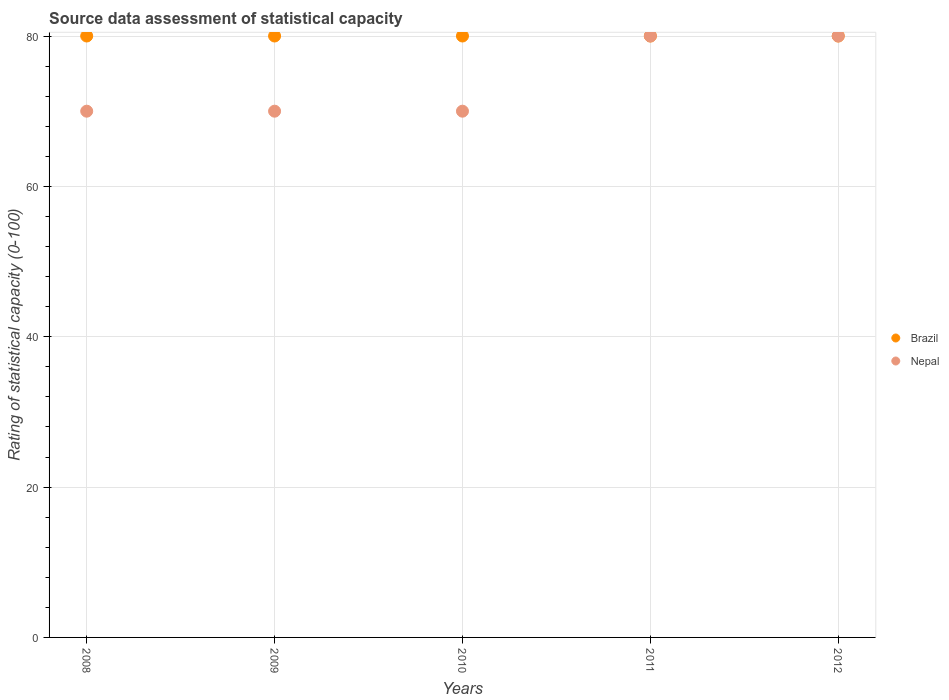How many different coloured dotlines are there?
Keep it short and to the point. 2. What is the rating of statistical capacity in Brazil in 2008?
Keep it short and to the point. 80. Across all years, what is the maximum rating of statistical capacity in Nepal?
Make the answer very short. 80. Across all years, what is the minimum rating of statistical capacity in Nepal?
Give a very brief answer. 70. What is the total rating of statistical capacity in Nepal in the graph?
Your response must be concise. 370. What is the difference between the rating of statistical capacity in Brazil in 2008 and that in 2009?
Offer a very short reply. 0. What is the difference between the rating of statistical capacity in Nepal in 2010 and the rating of statistical capacity in Brazil in 2008?
Offer a terse response. -10. In the year 2012, what is the difference between the rating of statistical capacity in Brazil and rating of statistical capacity in Nepal?
Your answer should be compact. 0. In how many years, is the rating of statistical capacity in Brazil greater than 60?
Provide a succinct answer. 5. What is the difference between the highest and the second highest rating of statistical capacity in Brazil?
Your answer should be compact. 0. What is the difference between the highest and the lowest rating of statistical capacity in Brazil?
Ensure brevity in your answer.  0. Does the rating of statistical capacity in Nepal monotonically increase over the years?
Give a very brief answer. No. Is the rating of statistical capacity in Brazil strictly greater than the rating of statistical capacity in Nepal over the years?
Offer a terse response. No. Is the rating of statistical capacity in Nepal strictly less than the rating of statistical capacity in Brazil over the years?
Provide a succinct answer. No. How many dotlines are there?
Provide a succinct answer. 2. How many years are there in the graph?
Offer a very short reply. 5. Does the graph contain grids?
Your answer should be compact. Yes. Where does the legend appear in the graph?
Offer a terse response. Center right. How are the legend labels stacked?
Your answer should be compact. Vertical. What is the title of the graph?
Offer a very short reply. Source data assessment of statistical capacity. Does "Portugal" appear as one of the legend labels in the graph?
Offer a very short reply. No. What is the label or title of the X-axis?
Give a very brief answer. Years. What is the label or title of the Y-axis?
Offer a terse response. Rating of statistical capacity (0-100). What is the Rating of statistical capacity (0-100) in Nepal in 2008?
Your answer should be compact. 70. What is the Rating of statistical capacity (0-100) of Nepal in 2009?
Your response must be concise. 70. What is the Rating of statistical capacity (0-100) in Brazil in 2010?
Ensure brevity in your answer.  80. What is the Rating of statistical capacity (0-100) in Nepal in 2010?
Keep it short and to the point. 70. What is the total Rating of statistical capacity (0-100) of Brazil in the graph?
Make the answer very short. 400. What is the total Rating of statistical capacity (0-100) of Nepal in the graph?
Your response must be concise. 370. What is the difference between the Rating of statistical capacity (0-100) in Brazil in 2008 and that in 2009?
Ensure brevity in your answer.  0. What is the difference between the Rating of statistical capacity (0-100) in Nepal in 2008 and that in 2009?
Give a very brief answer. 0. What is the difference between the Rating of statistical capacity (0-100) of Nepal in 2008 and that in 2010?
Offer a terse response. 0. What is the difference between the Rating of statistical capacity (0-100) in Brazil in 2009 and that in 2010?
Offer a very short reply. 0. What is the difference between the Rating of statistical capacity (0-100) of Nepal in 2009 and that in 2011?
Make the answer very short. -10. What is the difference between the Rating of statistical capacity (0-100) of Brazil in 2010 and that in 2011?
Make the answer very short. 0. What is the difference between the Rating of statistical capacity (0-100) of Nepal in 2010 and that in 2011?
Ensure brevity in your answer.  -10. What is the difference between the Rating of statistical capacity (0-100) of Brazil in 2010 and that in 2012?
Provide a succinct answer. 0. What is the difference between the Rating of statistical capacity (0-100) in Nepal in 2010 and that in 2012?
Provide a short and direct response. -10. What is the difference between the Rating of statistical capacity (0-100) in Brazil in 2011 and that in 2012?
Your answer should be compact. 0. What is the difference between the Rating of statistical capacity (0-100) in Brazil in 2008 and the Rating of statistical capacity (0-100) in Nepal in 2009?
Keep it short and to the point. 10. What is the difference between the Rating of statistical capacity (0-100) of Brazil in 2008 and the Rating of statistical capacity (0-100) of Nepal in 2010?
Your answer should be compact. 10. What is the difference between the Rating of statistical capacity (0-100) in Brazil in 2008 and the Rating of statistical capacity (0-100) in Nepal in 2011?
Keep it short and to the point. 0. What is the difference between the Rating of statistical capacity (0-100) in Brazil in 2009 and the Rating of statistical capacity (0-100) in Nepal in 2011?
Offer a very short reply. 0. What is the difference between the Rating of statistical capacity (0-100) in Brazil in 2009 and the Rating of statistical capacity (0-100) in Nepal in 2012?
Your answer should be compact. 0. What is the difference between the Rating of statistical capacity (0-100) of Brazil in 2010 and the Rating of statistical capacity (0-100) of Nepal in 2012?
Your response must be concise. 0. What is the difference between the Rating of statistical capacity (0-100) of Brazil in 2011 and the Rating of statistical capacity (0-100) of Nepal in 2012?
Offer a terse response. 0. What is the average Rating of statistical capacity (0-100) of Nepal per year?
Your answer should be very brief. 74. In the year 2008, what is the difference between the Rating of statistical capacity (0-100) in Brazil and Rating of statistical capacity (0-100) in Nepal?
Offer a very short reply. 10. What is the ratio of the Rating of statistical capacity (0-100) of Brazil in 2008 to that in 2010?
Offer a terse response. 1. What is the ratio of the Rating of statistical capacity (0-100) in Brazil in 2008 to that in 2011?
Make the answer very short. 1. What is the ratio of the Rating of statistical capacity (0-100) of Nepal in 2008 to that in 2012?
Ensure brevity in your answer.  0.88. What is the ratio of the Rating of statistical capacity (0-100) in Nepal in 2009 to that in 2010?
Keep it short and to the point. 1. What is the ratio of the Rating of statistical capacity (0-100) in Nepal in 2009 to that in 2011?
Give a very brief answer. 0.88. What is the ratio of the Rating of statistical capacity (0-100) in Nepal in 2009 to that in 2012?
Give a very brief answer. 0.88. What is the ratio of the Rating of statistical capacity (0-100) in Nepal in 2010 to that in 2011?
Offer a very short reply. 0.88. What is the ratio of the Rating of statistical capacity (0-100) in Nepal in 2010 to that in 2012?
Keep it short and to the point. 0.88. What is the ratio of the Rating of statistical capacity (0-100) in Brazil in 2011 to that in 2012?
Offer a terse response. 1. What is the difference between the highest and the second highest Rating of statistical capacity (0-100) of Brazil?
Keep it short and to the point. 0. What is the difference between the highest and the second highest Rating of statistical capacity (0-100) in Nepal?
Your response must be concise. 0. What is the difference between the highest and the lowest Rating of statistical capacity (0-100) in Brazil?
Your answer should be compact. 0. 